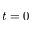<formula> <loc_0><loc_0><loc_500><loc_500>t = 0</formula> 